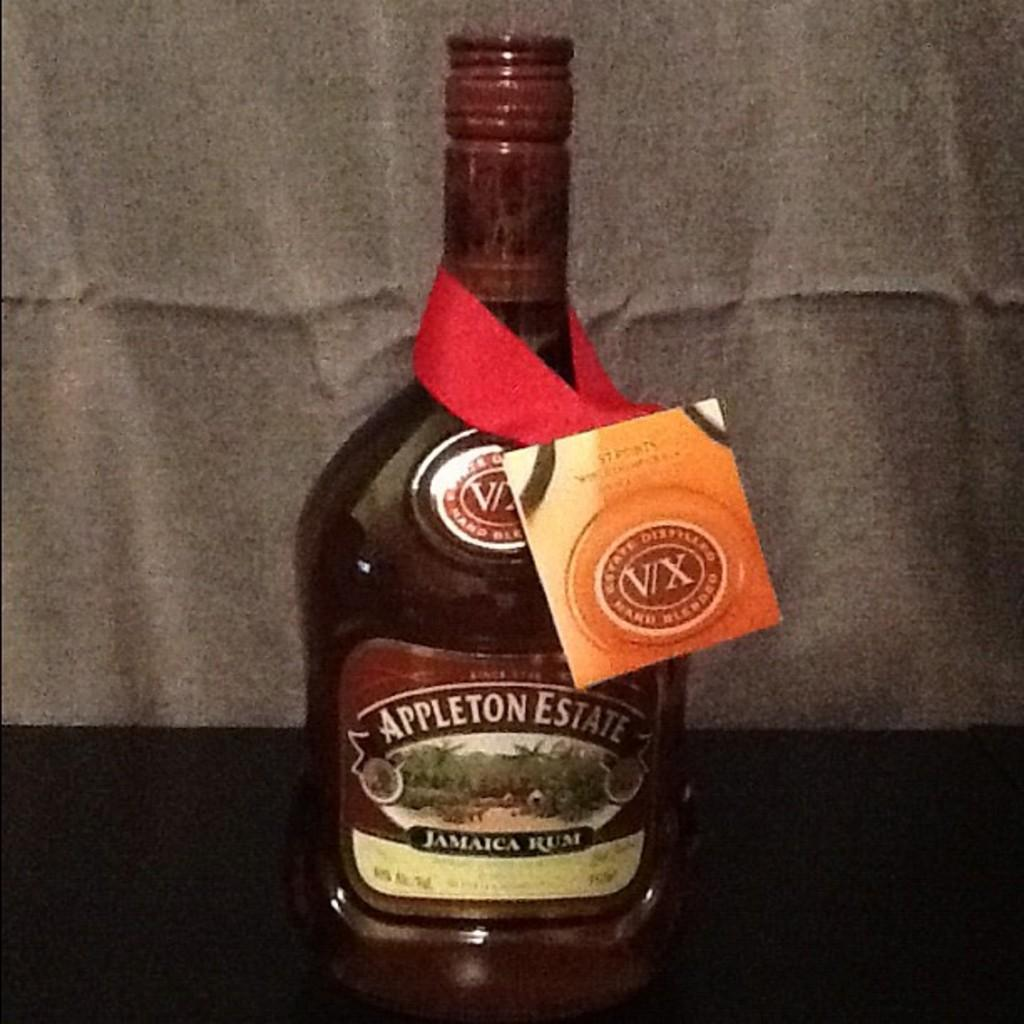<image>
Present a compact description of the photo's key features. A bottle is labelled as being from the Appleton Estate. 